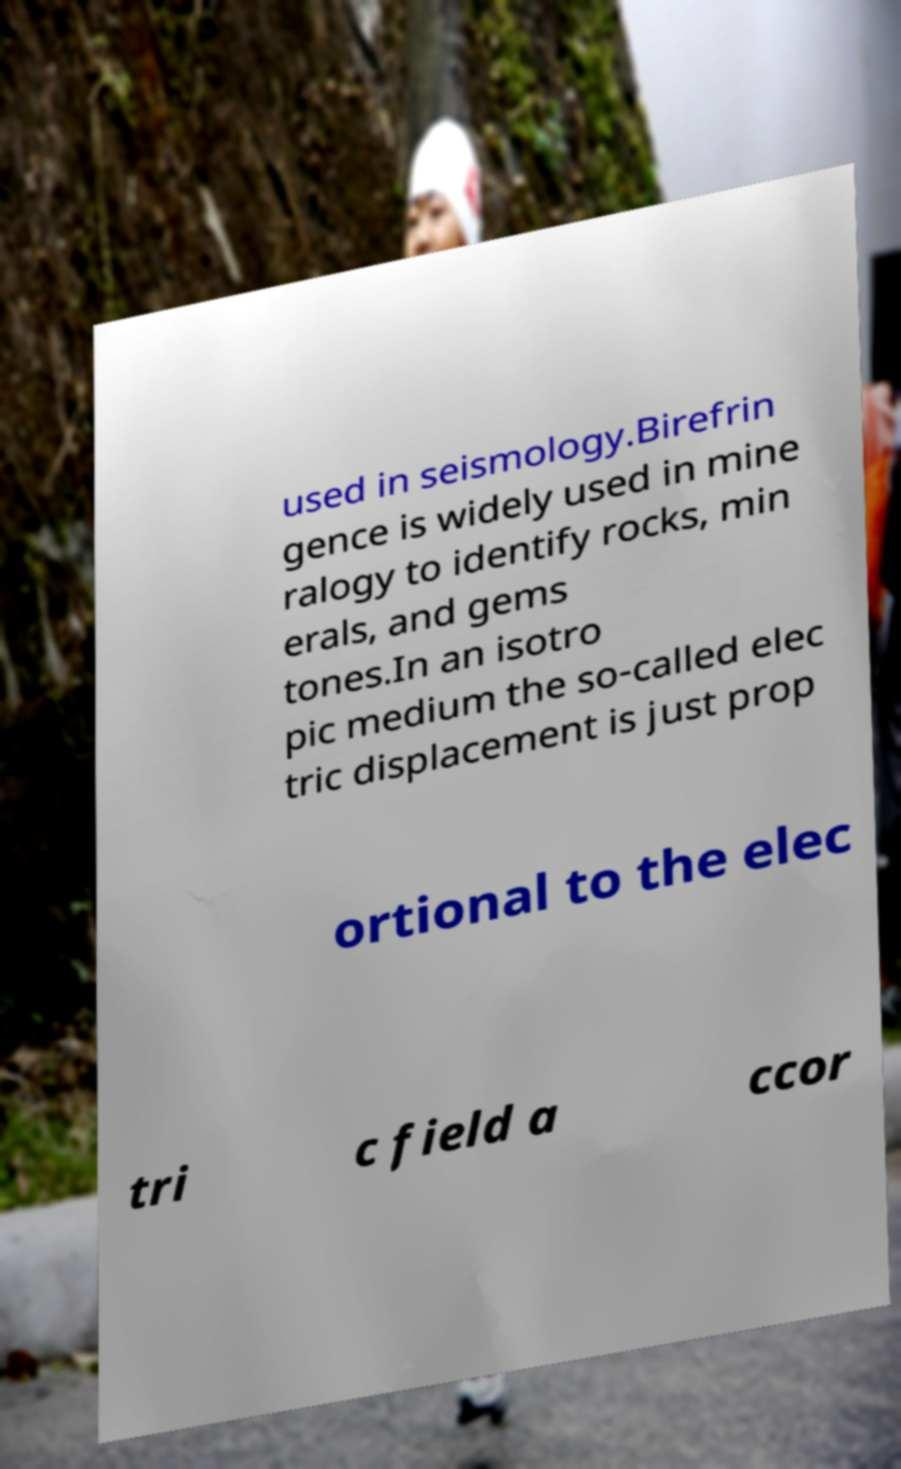Could you assist in decoding the text presented in this image and type it out clearly? used in seismology.Birefrin gence is widely used in mine ralogy to identify rocks, min erals, and gems tones.In an isotro pic medium the so-called elec tric displacement is just prop ortional to the elec tri c field a ccor 